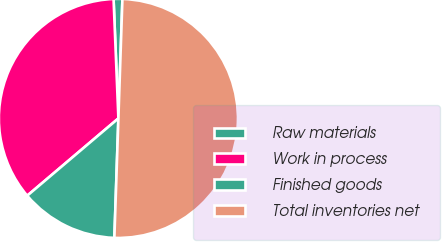Convert chart. <chart><loc_0><loc_0><loc_500><loc_500><pie_chart><fcel>Raw materials<fcel>Work in process<fcel>Finished goods<fcel>Total inventories net<nl><fcel>1.18%<fcel>35.55%<fcel>13.27%<fcel>50.0%<nl></chart> 